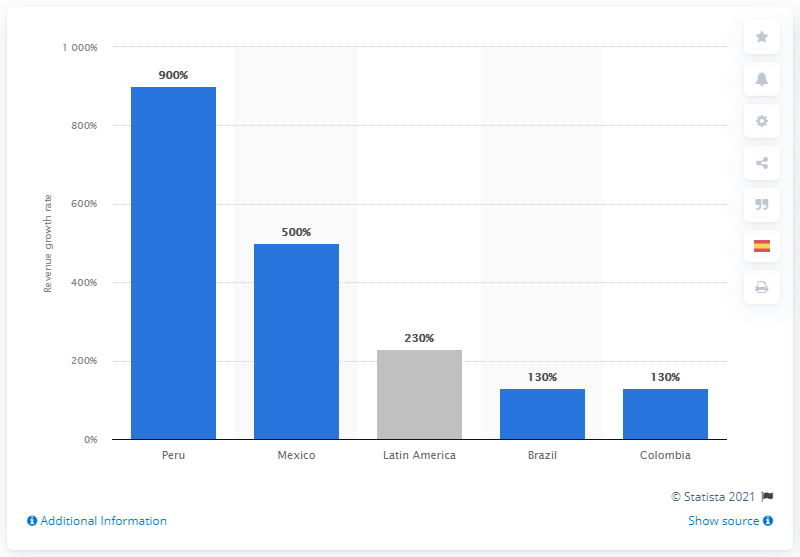List a handful of essential elements in this visual. The e-commerce revenue in Peru has increased by 900%. Latin American e-commerce revenue experienced a growth rate of 230% in 2020. 